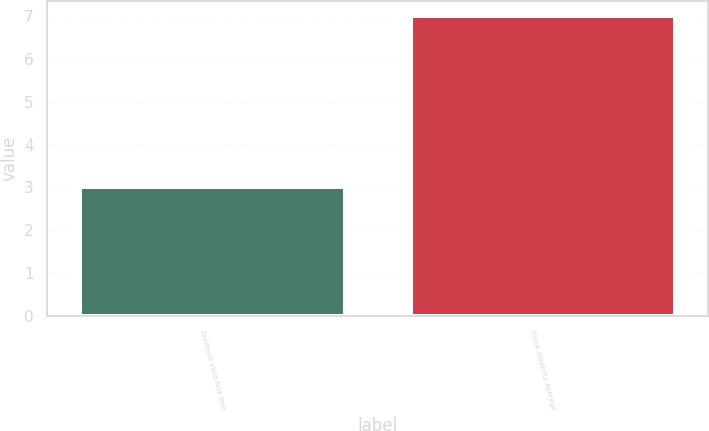Convert chart to OTSL. <chart><loc_0><loc_0><loc_500><loc_500><bar_chart><fcel>Dividend yield Risk-free<fcel>Stock volatility Average<nl><fcel>3<fcel>7<nl></chart> 